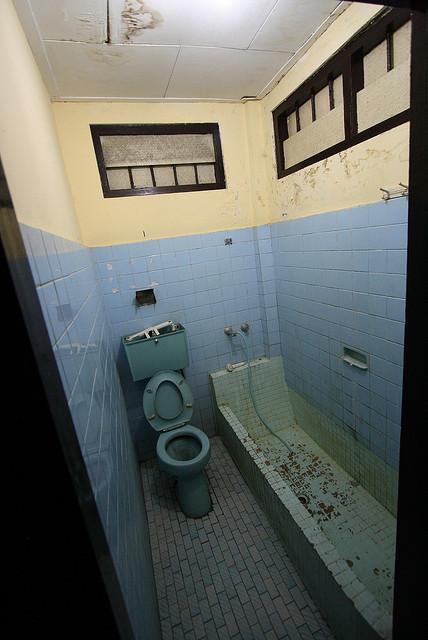How many toilets are seen?
Give a very brief answer. 1. How many giraffes are standing?
Give a very brief answer. 0. 